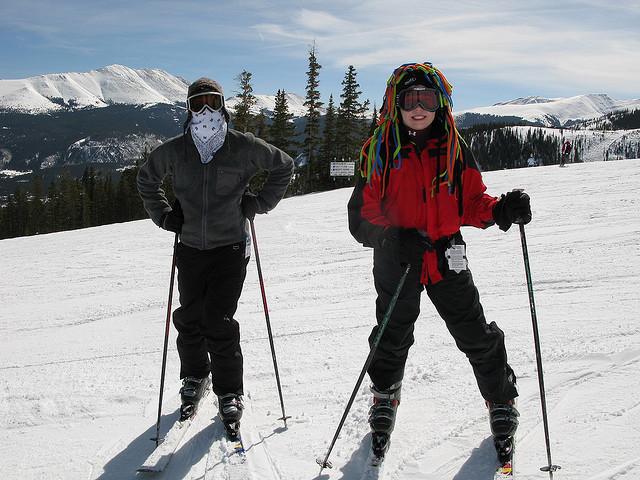What kind of sport are they partaking in?
Quick response, please. Skiing. What color is the jacket of the woman on the left?
Short answer required. Gray. Are they skiing?
Write a very short answer. Yes. How many people are posed?
Concise answer only. 2. What is over the mouth of the person on the left?
Keep it brief. Bandana. 